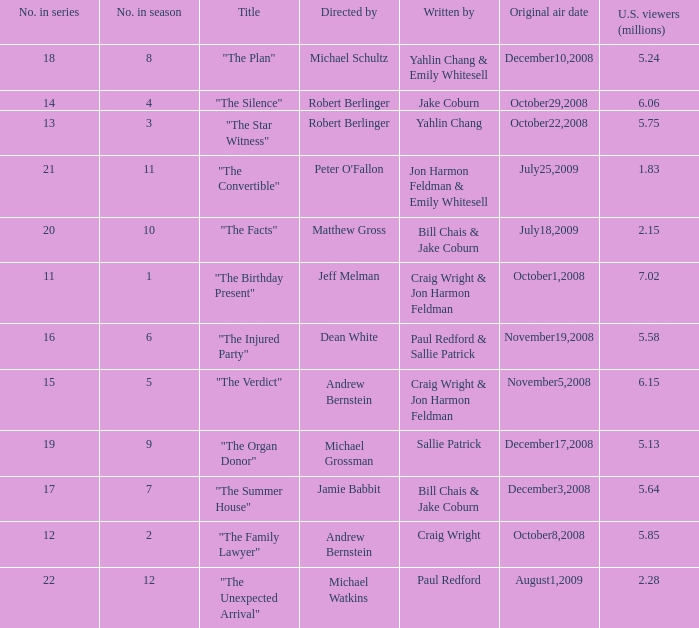What number episode in the season is "The Family Lawyer"? 2.0. 